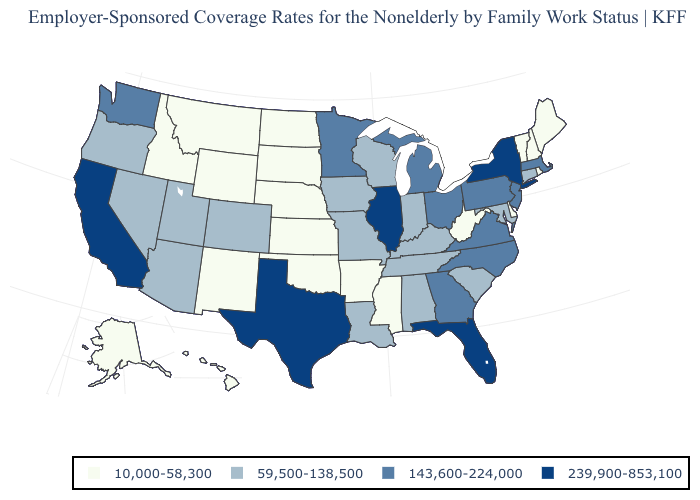Does Delaware have the lowest value in the South?
Concise answer only. Yes. Does Kansas have the lowest value in the USA?
Be succinct. Yes. Name the states that have a value in the range 239,900-853,100?
Concise answer only. California, Florida, Illinois, New York, Texas. What is the value of Pennsylvania?
Write a very short answer. 143,600-224,000. What is the lowest value in the USA?
Answer briefly. 10,000-58,300. Does Ohio have the lowest value in the USA?
Concise answer only. No. Is the legend a continuous bar?
Concise answer only. No. What is the lowest value in states that border Washington?
Concise answer only. 10,000-58,300. What is the value of New York?
Concise answer only. 239,900-853,100. Does the map have missing data?
Give a very brief answer. No. What is the value of Maine?
Short answer required. 10,000-58,300. Among the states that border Pennsylvania , does New York have the lowest value?
Short answer required. No. Name the states that have a value in the range 143,600-224,000?
Write a very short answer. Georgia, Massachusetts, Michigan, Minnesota, New Jersey, North Carolina, Ohio, Pennsylvania, Virginia, Washington. Name the states that have a value in the range 239,900-853,100?
Quick response, please. California, Florida, Illinois, New York, Texas. Name the states that have a value in the range 239,900-853,100?
Short answer required. California, Florida, Illinois, New York, Texas. 